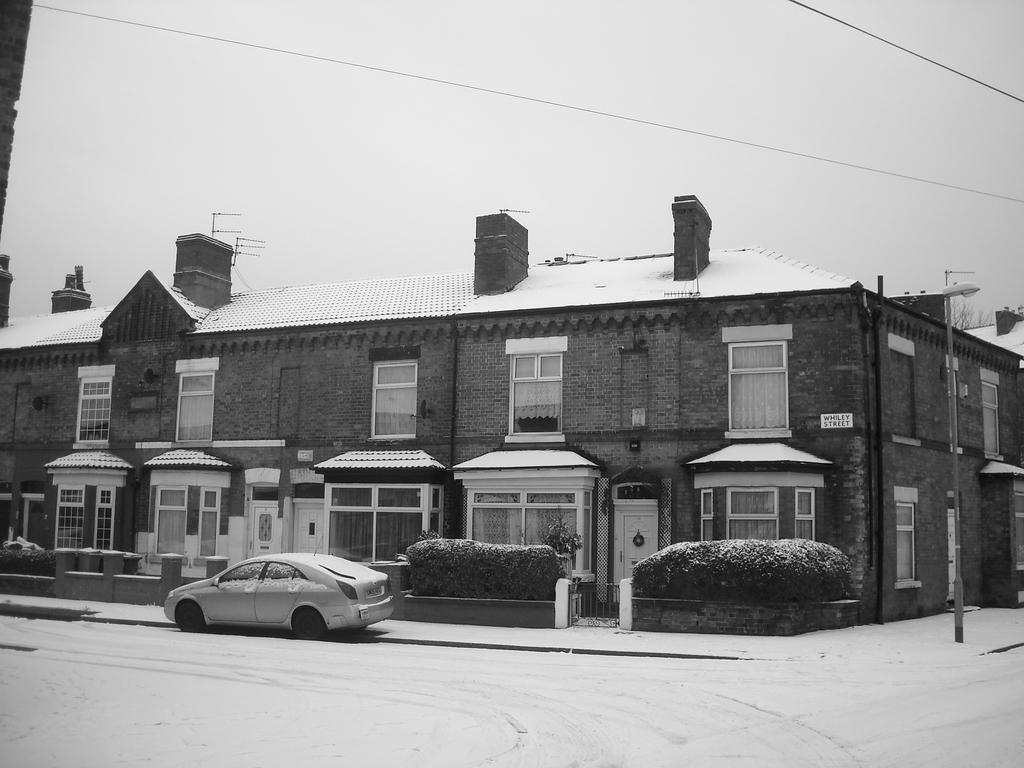How would you summarize this image in a sentence or two? In this image there is a building, in front of the building there are trees, plants and a vehicle is parked. In the background there is the sky. 